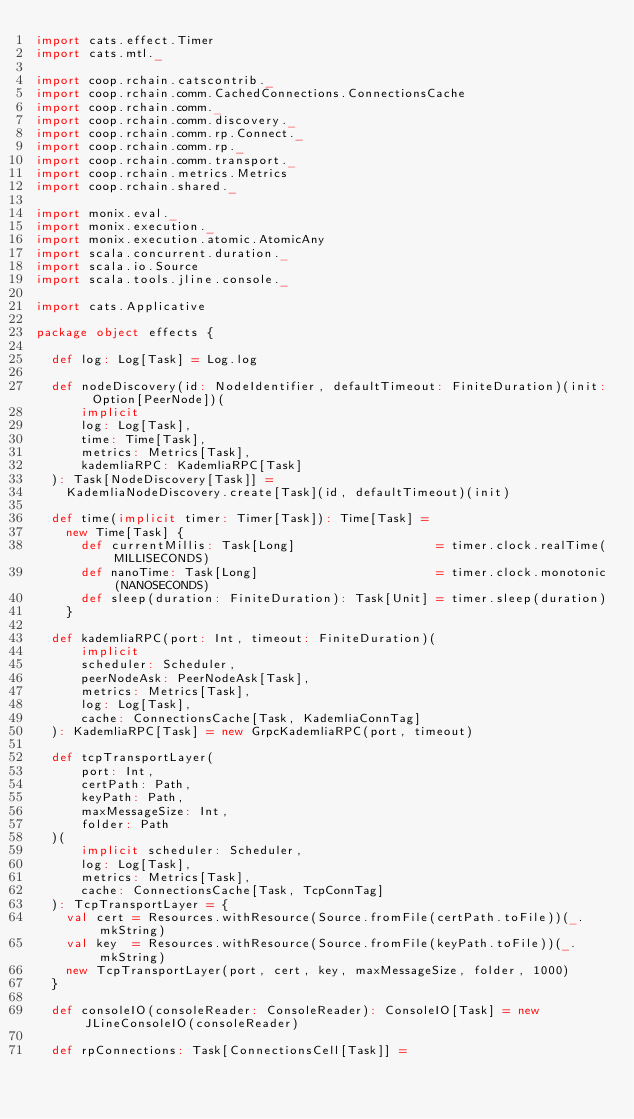<code> <loc_0><loc_0><loc_500><loc_500><_Scala_>import cats.effect.Timer
import cats.mtl._

import coop.rchain.catscontrib._
import coop.rchain.comm.CachedConnections.ConnectionsCache
import coop.rchain.comm._
import coop.rchain.comm.discovery._
import coop.rchain.comm.rp.Connect._
import coop.rchain.comm.rp._
import coop.rchain.comm.transport._
import coop.rchain.metrics.Metrics
import coop.rchain.shared._

import monix.eval._
import monix.execution._
import monix.execution.atomic.AtomicAny
import scala.concurrent.duration._
import scala.io.Source
import scala.tools.jline.console._

import cats.Applicative

package object effects {

  def log: Log[Task] = Log.log

  def nodeDiscovery(id: NodeIdentifier, defaultTimeout: FiniteDuration)(init: Option[PeerNode])(
      implicit
      log: Log[Task],
      time: Time[Task],
      metrics: Metrics[Task],
      kademliaRPC: KademliaRPC[Task]
  ): Task[NodeDiscovery[Task]] =
    KademliaNodeDiscovery.create[Task](id, defaultTimeout)(init)

  def time(implicit timer: Timer[Task]): Time[Task] =
    new Time[Task] {
      def currentMillis: Task[Long]                   = timer.clock.realTime(MILLISECONDS)
      def nanoTime: Task[Long]                        = timer.clock.monotonic(NANOSECONDS)
      def sleep(duration: FiniteDuration): Task[Unit] = timer.sleep(duration)
    }

  def kademliaRPC(port: Int, timeout: FiniteDuration)(
      implicit
      scheduler: Scheduler,
      peerNodeAsk: PeerNodeAsk[Task],
      metrics: Metrics[Task],
      log: Log[Task],
      cache: ConnectionsCache[Task, KademliaConnTag]
  ): KademliaRPC[Task] = new GrpcKademliaRPC(port, timeout)

  def tcpTransportLayer(
      port: Int,
      certPath: Path,
      keyPath: Path,
      maxMessageSize: Int,
      folder: Path
  )(
      implicit scheduler: Scheduler,
      log: Log[Task],
      metrics: Metrics[Task],
      cache: ConnectionsCache[Task, TcpConnTag]
  ): TcpTransportLayer = {
    val cert = Resources.withResource(Source.fromFile(certPath.toFile))(_.mkString)
    val key  = Resources.withResource(Source.fromFile(keyPath.toFile))(_.mkString)
    new TcpTransportLayer(port, cert, key, maxMessageSize, folder, 1000)
  }

  def consoleIO(consoleReader: ConsoleReader): ConsoleIO[Task] = new JLineConsoleIO(consoleReader)

  def rpConnections: Task[ConnectionsCell[Task]] =</code> 